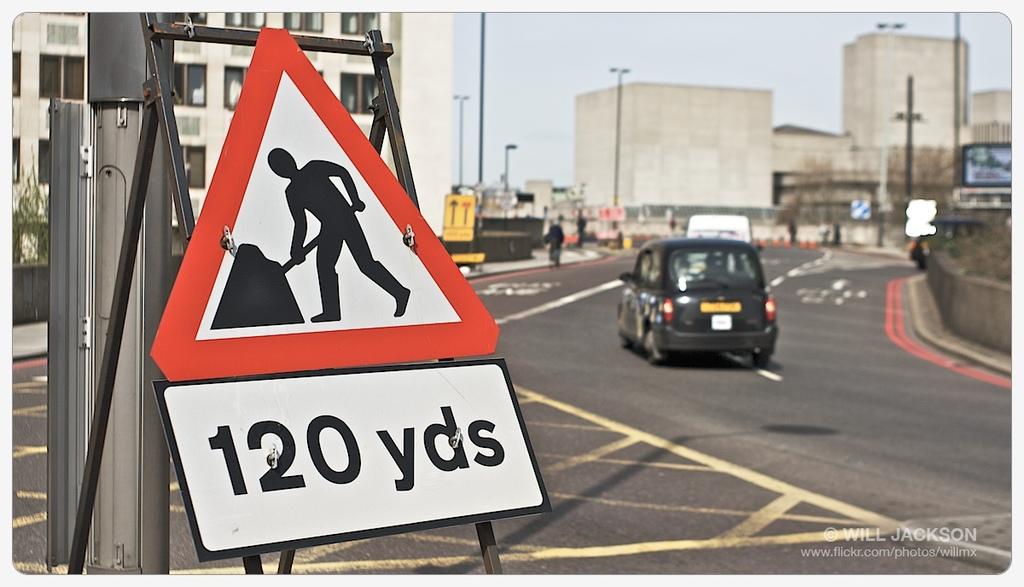How many yards away is the construction?
Your answer should be compact. 120. What is on the sign?
Your answer should be very brief. 120 yds. 